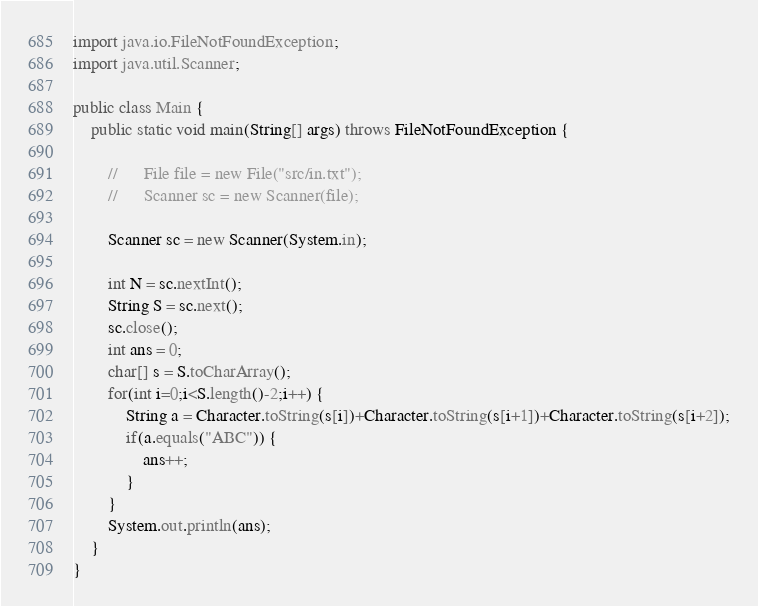Convert code to text. <code><loc_0><loc_0><loc_500><loc_500><_Java_>import java.io.FileNotFoundException;
import java.util.Scanner;

public class Main {
	public static void main(String[] args) throws FileNotFoundException {

		//    	File file = new File("src/in.txt");
		//    	Scanner sc = new Scanner(file);

		Scanner sc = new Scanner(System.in);

		int N = sc.nextInt();
		String S = sc.next();
		sc.close();
		int ans = 0;
		char[] s = S.toCharArray();
		for(int i=0;i<S.length()-2;i++) {
			String a = Character.toString(s[i])+Character.toString(s[i+1])+Character.toString(s[i+2]);
			if(a.equals("ABC")) {
				ans++;
			}
		}
		System.out.println(ans);
	}
}</code> 